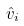Convert formula to latex. <formula><loc_0><loc_0><loc_500><loc_500>\hat { v } _ { i }</formula> 